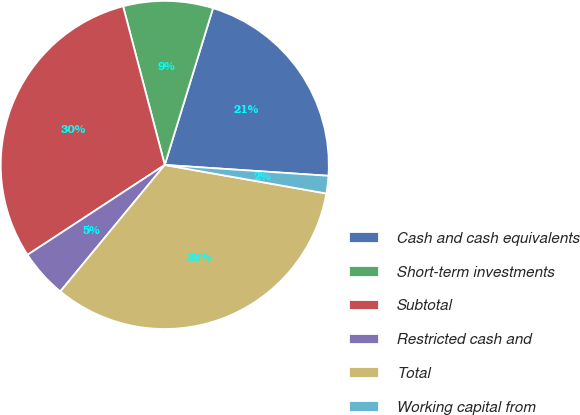<chart> <loc_0><loc_0><loc_500><loc_500><pie_chart><fcel>Cash and cash equivalents<fcel>Short-term investments<fcel>Subtotal<fcel>Restricted cash and<fcel>Total<fcel>Working capital from<nl><fcel>21.3%<fcel>8.84%<fcel>30.14%<fcel>4.79%<fcel>33.2%<fcel>1.73%<nl></chart> 